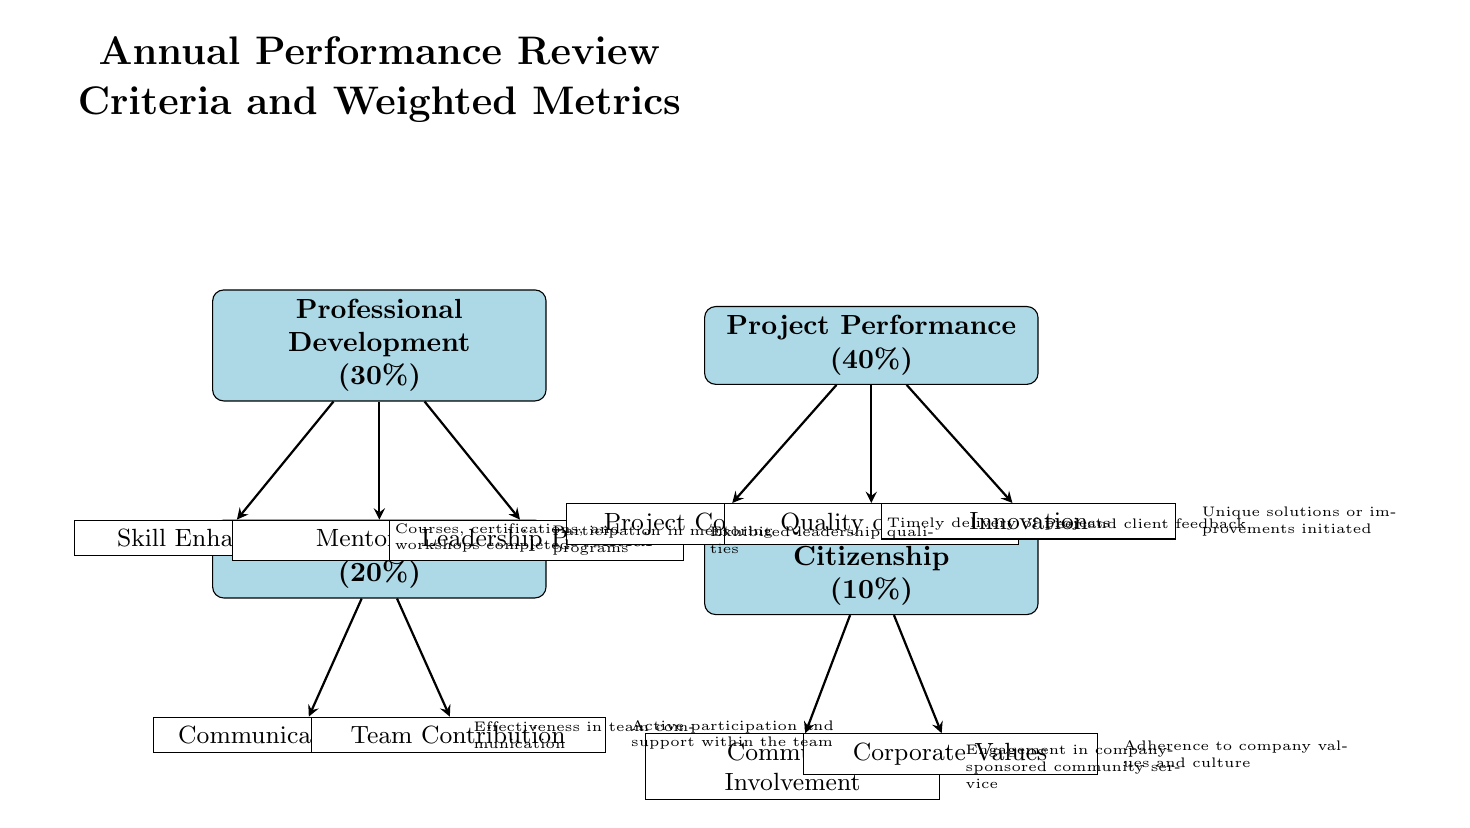What is the weight of Project Performance in the review criteria? The diagram clearly states that Project Performance has a weight of 40% as indicated in the main category node.
Answer: 40% How many criteria fall under Team Collaboration? The diagram shows two criteria listed below the Team Collaboration node: Communication Skills and Team Contribution. Therefore, there are 2 criteria.
Answer: 2 What is the description associated with Leadership Potential? The diagram indicates that the description for Leadership Potential is "Exhibited leadership qualities," which is aligned next to that criterion.
Answer: Exhibited leadership qualities Which criterion has the highest weight? By analyzing the weights assigned to each main category, Project Performance has the highest weight of 40%.
Answer: Project Performance What are the two criteria listed under Organizational Citizenship? The diagram identifies the two criteria under Organizational Citizenship as Community Involvement and Corporate Values.
Answer: Community Involvement, Corporate Values Which criterion focuses on timely delivery of projects? The criterion that specifically addresses timely project delivery is Project Completion, which is listed under the Project Performance category.
Answer: Project Completion What percentage does Team Collaboration represent in the overall metrics? The diagram shows that Team Collaboration has a weight of 20% in the overall performance metrics.
Answer: 20% What does the term "Corporate Values" refer to in this diagram? Corporate Values is one of the criteria listed under Organizational Citizenship, and it reflects the adherence to company values and culture as described in the diagram.
Answer: Adherence to company values and culture How does one measure the quality of work according to the diagram? The quality of work is assessed based on peer and client feedback, which is specifically cited under the Quality of Work criterion in the Project Performance category.
Answer: Peer and client feedback 